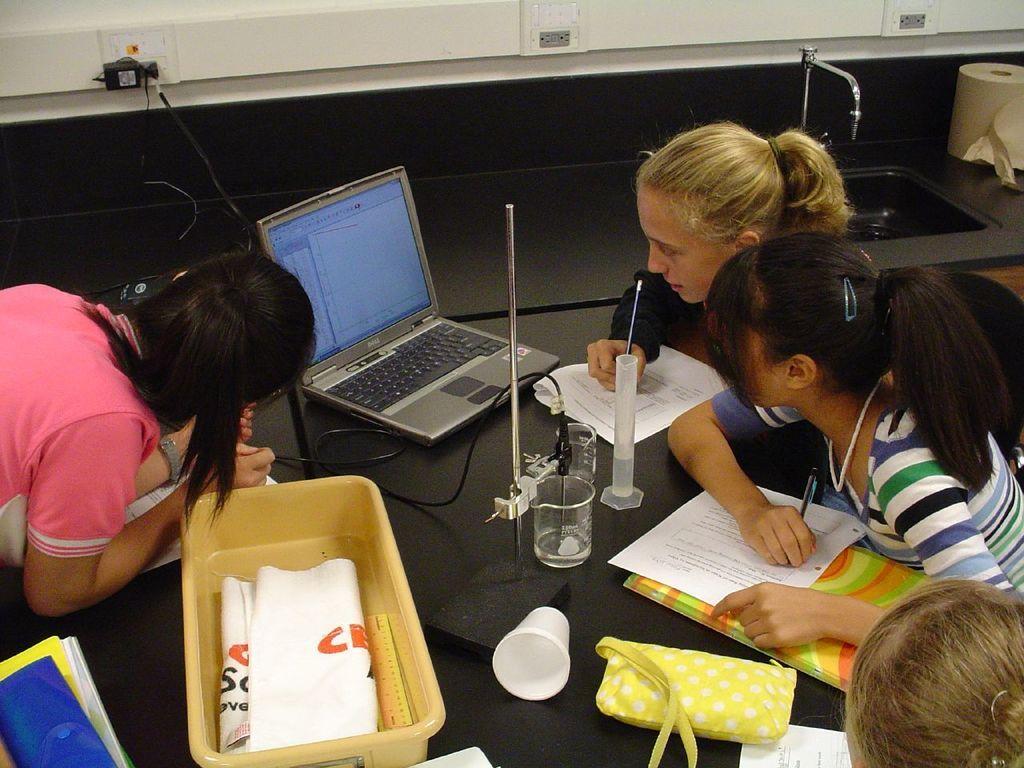Could you give a brief overview of what you see in this image? In the foreground of the picture there are girls, in between them there is a desk, on the desk there are apparatus, books, cup, bag, laptop, cable and other objects. The girls are holding pens. On the right there is a sink and tissue paper. At the top there are plug boxes. 